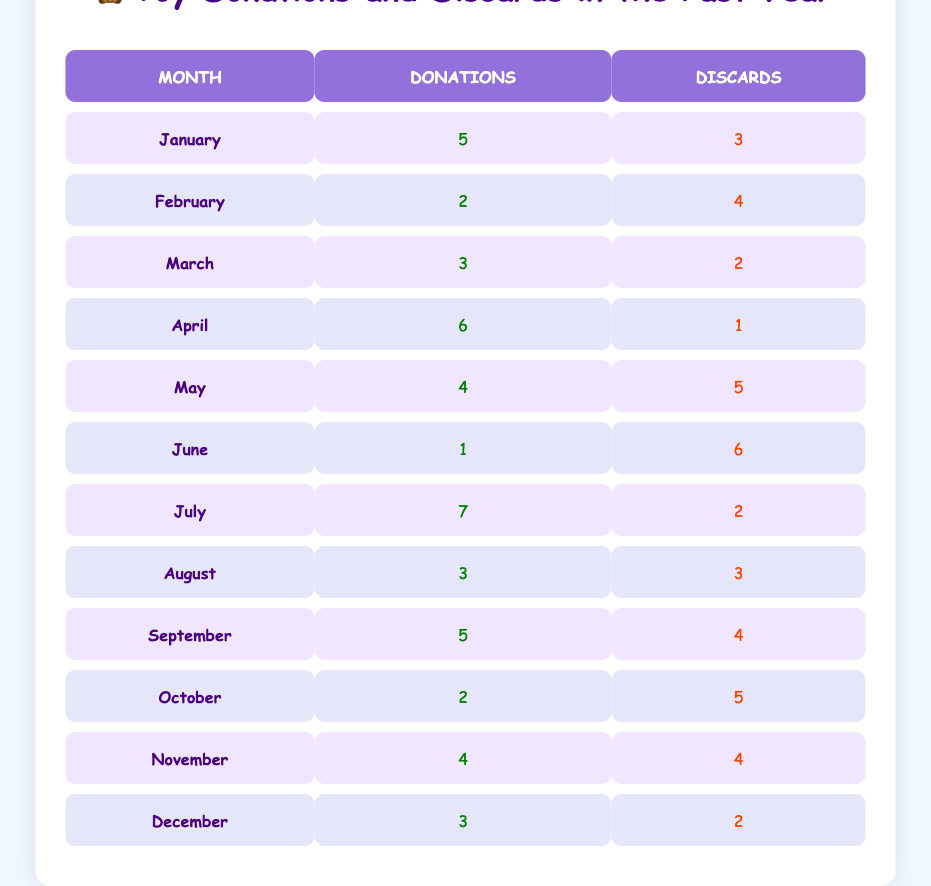What was the total number of toy donations in January? In January, the table states there were 5 donations. Therefore, the total number of toy donations is simply stated in that cell.
Answer: 5 How many toys were discarded in June? The table indicates that in June, there were 6 discarded toys. This value is directly found in the corresponding cell for June's discards.
Answer: 6 Which month had the highest number of donations? By examining the donations column, July has the highest number of donations at 7 toys. The other months have fewer, confirming July's position.
Answer: July What is the total number of donations and discards in February? In February, there were 2 donations and 4 discards. Adding these values together gives 2 + 4 = 6. This calculation leads to the total for that month.
Answer: 6 Did the number of donations ever exceed the number of discards in any month? Yes, in multiple months, including January (5 donations, 3 discards), April (6 donations, 1 discard), and July (7 donations, 2 discards), the donations exceed the discards.
Answer: Yes In which month was the difference between donations and discards the largest? By calculating the absolute differences for each month, we find that June had a difference of 5 toys (6 discards vs 1 donation). The difference of 5 toys is larger than any other month.
Answer: June What is the average number of toys discarded per month in the past year? To find the average, first sum all discards: 3 + 4 + 2 + 1 + 5 + 6 + 2 + 3 + 4 + 5 + 4 + 2 = 43. Since there are 12 months, divide 43 by 12 to get approximately 3.58.
Answer: Approximately 3.58 How many more toys were donated than discarded during the month of April? In April, there were 6 donations and only 1 discard. The difference is 6 - 1 = 5, indicating that 5 more toys were donated than discarded that month.
Answer: 5 Did the months of August and November have the same number of donations? Yes, both August and November reported 3 and 4 donations, respectively, indicating no difference in total donations between these two months.
Answer: No 